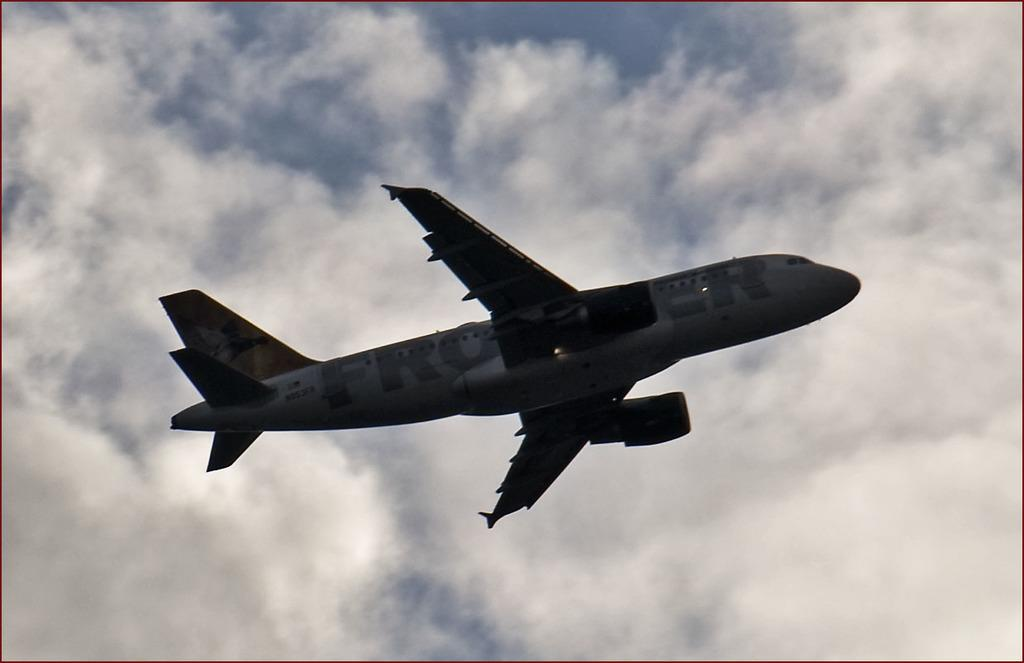Provide a one-sentence caption for the provided image. A passenger airplane bearing a word that starts with the letters "FRO" is flying in the sky. 